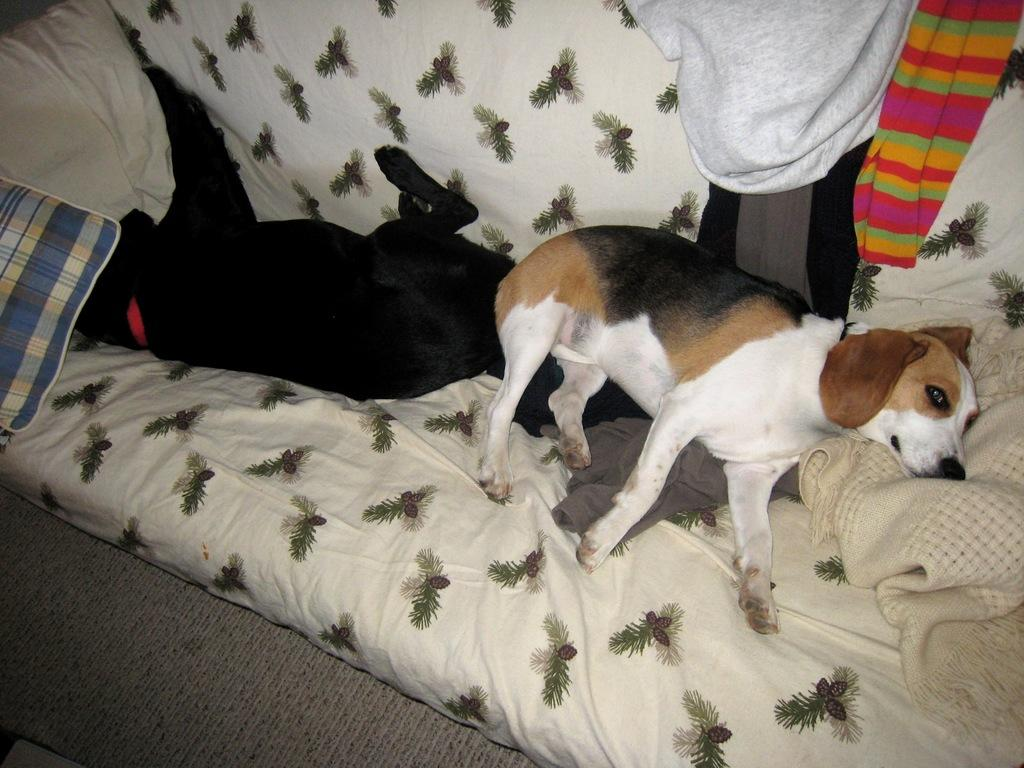How many dogs are present in the image? There are two dogs in the image. What are the dogs doing in the image? The dogs are lying on a sofa. What else can be seen in the image besides the dogs? Blankets and clothes are visible in the image. Where was the image taken? The image was taken in a room. What is the distribution of profits among the dogs in the image? There is no mention of profits or distribution in the image, as it features two dogs lying on a sofa with blankets and clothes visible. 